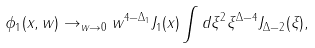Convert formula to latex. <formula><loc_0><loc_0><loc_500><loc_500>\phi _ { 1 } ( x , w ) \rightarrow _ { w \rightarrow 0 } w ^ { 4 - \Delta _ { 1 } } J _ { 1 } ( x ) \int d \xi ^ { 2 } \xi ^ { \Delta - 4 } J _ { \Delta - 2 } ( \xi ) ,</formula> 